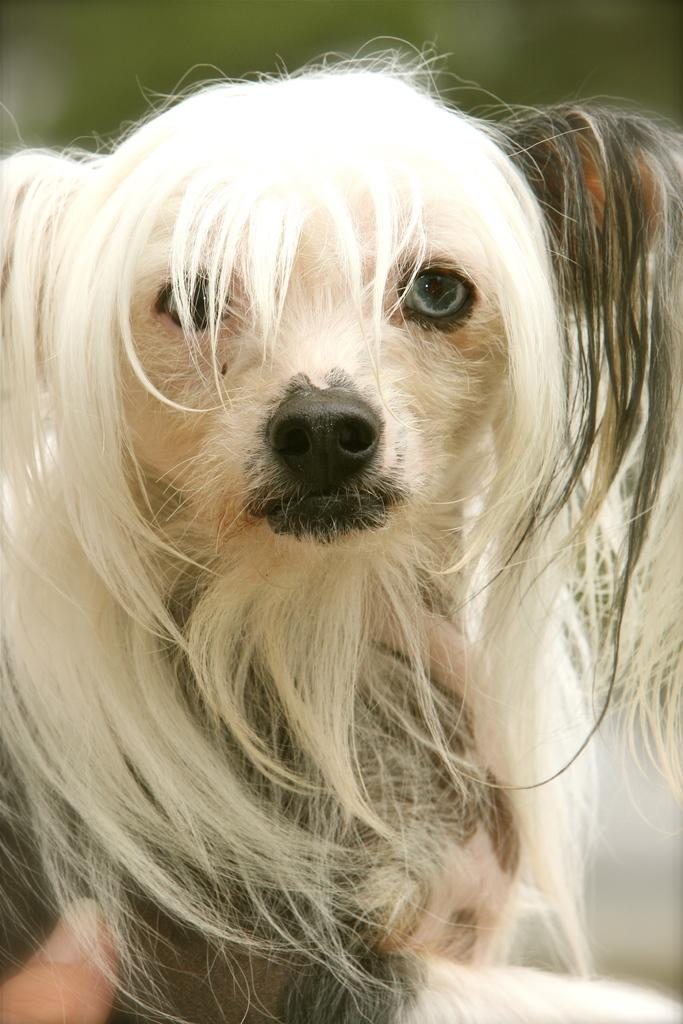What type of animal is in the picture? There is a dog in the picture. Can you describe any other elements in the picture? A person's thumb is visible in the bottom left corner of the picture. What color is the mountain in the background of the picture? There is no mountain present in the picture; it only features a dog and a person's thumb. 